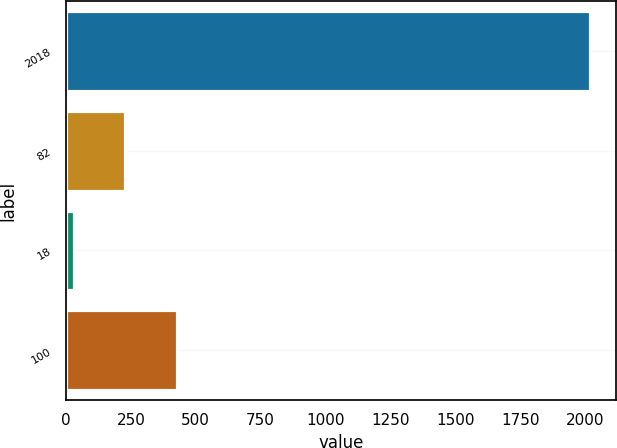Convert chart to OTSL. <chart><loc_0><loc_0><loc_500><loc_500><bar_chart><fcel>2018<fcel>82<fcel>18<fcel>100<nl><fcel>2017<fcel>228.7<fcel>30<fcel>427.4<nl></chart> 